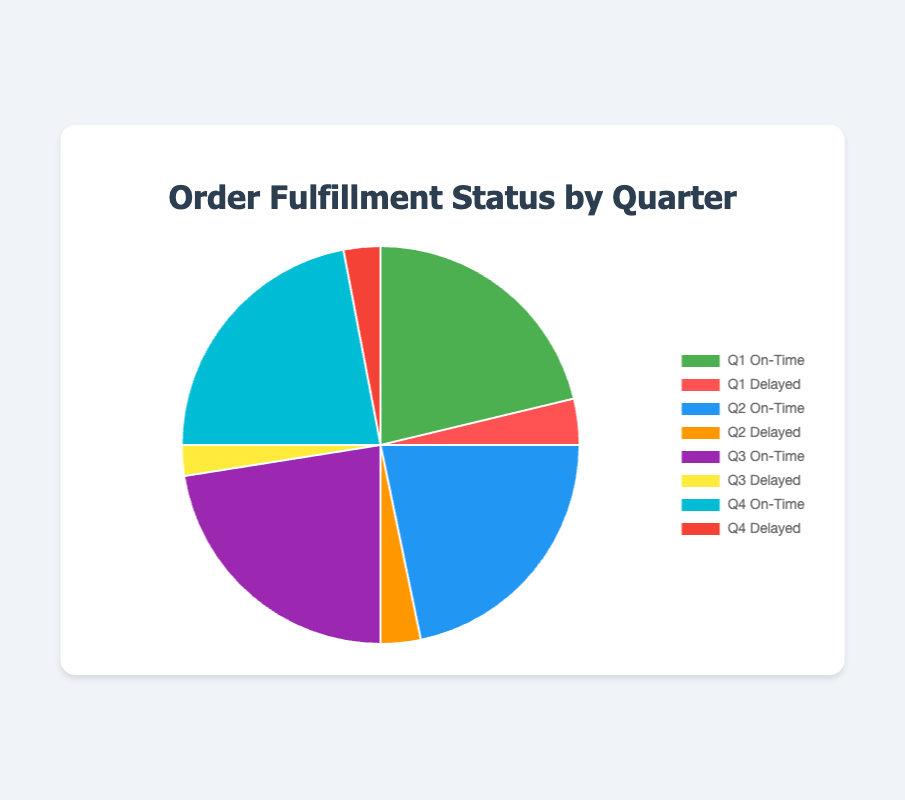Which quarter had the highest percentage of orders fulfilled on time? The quarter with the highest percentage of orders fulfilled on time is Q3 with 90%. This can be seen by comparing the on-time fulfillment rates for each quarter, where Q3 has the highest value.
Answer: Q3 What is the total percentage of orders that were delayed across all quarters? Summing up the delayed percentages for Q1, Q2, Q3, and Q4 gives 15% + 13% + 10% + 12% = 50%.
Answer: 50% In which quarter was the difference between fulfilled on time and delayed orders the smallest? Calculating the difference between fulfilled on time and delayed for each quarter: 
Q1: 85% - 15% = 70%
Q2: 87% - 13% = 74%
Q3: 90% - 10% = 80%
Q4: 88% - 12% = 76%
The smallest difference is in Q1 with 70%.
Answer: Q1 How does the on-time fulfillment rate in Q2 compare to Q4? The on-time fulfillment rate in Q2 is 87%, while in Q4 it is 88%. Therefore, Q4 has a slightly higher on-time fulfillment rate than Q2.
Answer: Q4 is higher What is the average percentage of orders fulfilled on time for the year? Adding the on-time percentages for all quarters and dividing by 4 gives (85% + 87% + 90% + 88%) / 4 = 87.5%.
Answer: 87.5% What is the color representing Q3 delayed orders in the pie chart? The color representing Q3 delayed orders in the pie chart is yellow, as it follows the sequence of colors: green, red, blue, orange, purple, yellow, cyan, and red.
Answer: Yellow Which quarter shows the largest visual segment for orders fulfilled on time? The largest visual segment for orders fulfilled on time in the pie chart corresponds to Q3, which has 90% fulfillment.
Answer: Q3 What is the percentage difference between Q1 and Q2 delayed orders? The percentage difference between Q1 and Q2 delayed orders is 15% - 13% = 2%.
Answer: 2% By how much did the percentage of delayed orders decrease from Q1 to Q3? The percentage of delayed orders in Q1 is 15% and in Q3 it is 10%. The difference is 15% - 10% = 5%.
Answer: 5% What is the proportion of orders fulfilled on time to delayed orders in Q4? In Q4, the orders fulfilled on time is 88% and delayed is 12%. The proportion is 88% / 12% = 7.33.
Answer: 7.33 